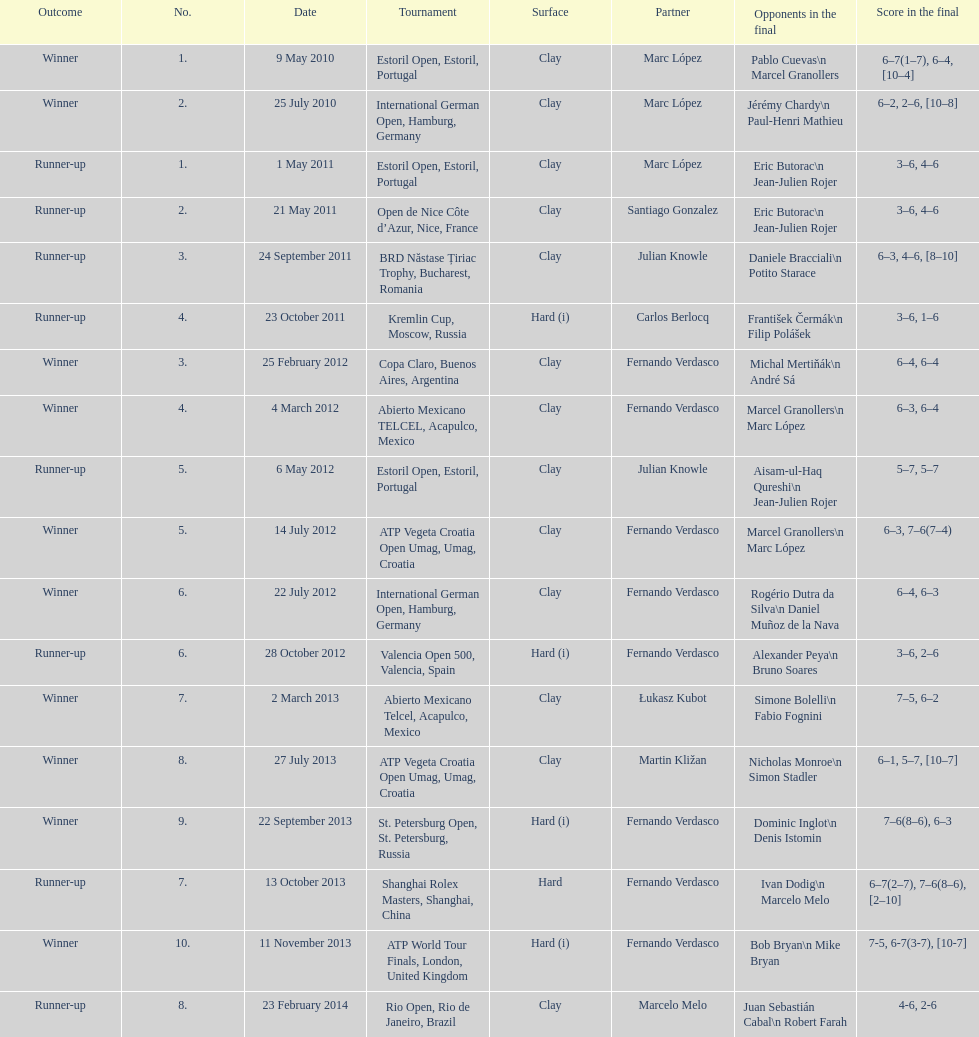How often was a hard surface employed? 5. 